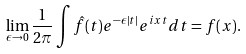<formula> <loc_0><loc_0><loc_500><loc_500>\lim _ { \epsilon \rightarrow 0 } \frac { 1 } { 2 \pi } \int \hat { f } ( t ) e ^ { - \epsilon | t | } e ^ { i x t } d t = f ( x ) .</formula> 